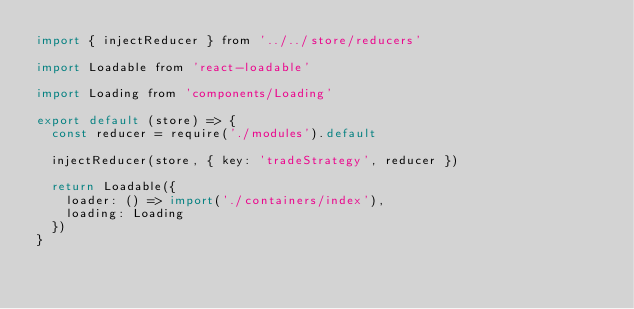<code> <loc_0><loc_0><loc_500><loc_500><_JavaScript_>import { injectReducer } from '../../store/reducers'

import Loadable from 'react-loadable'

import Loading from 'components/Loading'

export default (store) => {
  const reducer = require('./modules').default

  injectReducer(store, { key: 'tradeStrategy', reducer })

  return Loadable({
    loader: () => import('./containers/index'),
    loading: Loading
  })
}
</code> 